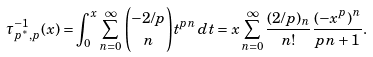Convert formula to latex. <formula><loc_0><loc_0><loc_500><loc_500>\tau _ { p ^ { * } , p } ^ { - 1 } { ( x ) } = \int _ { 0 } ^ { x } \sum _ { n = 0 } ^ { \infty } \binom { - 2 / p } { n } t ^ { p n } \, d t = x \sum _ { n = 0 } ^ { \infty } \frac { ( 2 / p ) _ { n } } { n ! } \frac { ( - x ^ { p } ) ^ { n } } { p n + 1 } .</formula> 